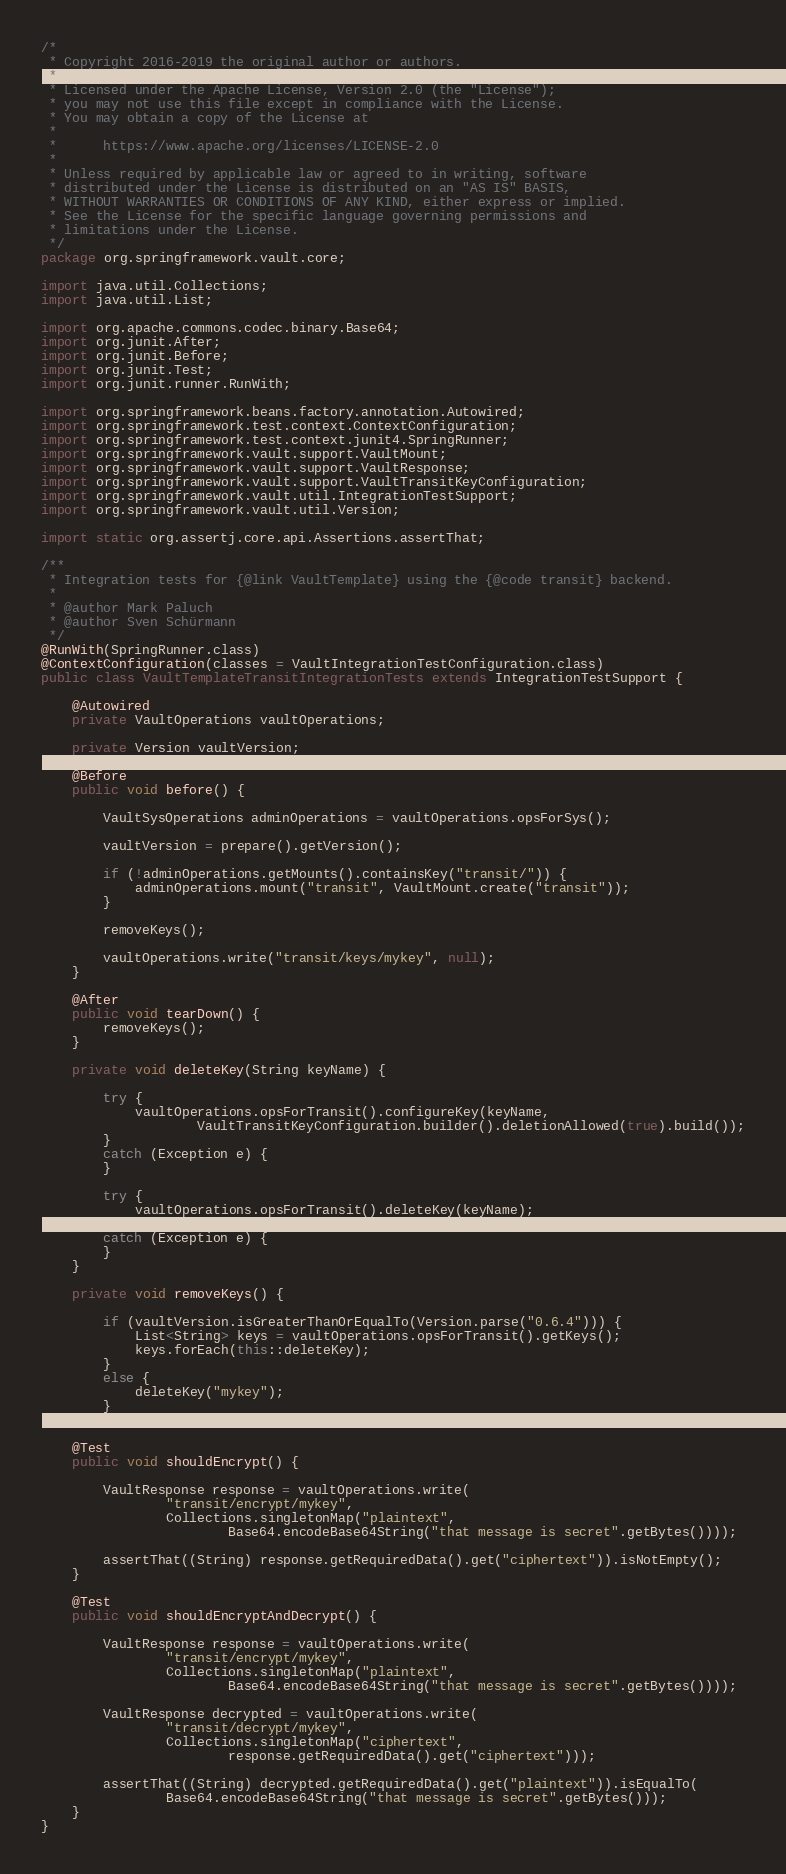Convert code to text. <code><loc_0><loc_0><loc_500><loc_500><_Java_>/*
 * Copyright 2016-2019 the original author or authors.
 *
 * Licensed under the Apache License, Version 2.0 (the "License");
 * you may not use this file except in compliance with the License.
 * You may obtain a copy of the License at
 *
 *      https://www.apache.org/licenses/LICENSE-2.0
 *
 * Unless required by applicable law or agreed to in writing, software
 * distributed under the License is distributed on an "AS IS" BASIS,
 * WITHOUT WARRANTIES OR CONDITIONS OF ANY KIND, either express or implied.
 * See the License for the specific language governing permissions and
 * limitations under the License.
 */
package org.springframework.vault.core;

import java.util.Collections;
import java.util.List;

import org.apache.commons.codec.binary.Base64;
import org.junit.After;
import org.junit.Before;
import org.junit.Test;
import org.junit.runner.RunWith;

import org.springframework.beans.factory.annotation.Autowired;
import org.springframework.test.context.ContextConfiguration;
import org.springframework.test.context.junit4.SpringRunner;
import org.springframework.vault.support.VaultMount;
import org.springframework.vault.support.VaultResponse;
import org.springframework.vault.support.VaultTransitKeyConfiguration;
import org.springframework.vault.util.IntegrationTestSupport;
import org.springframework.vault.util.Version;

import static org.assertj.core.api.Assertions.assertThat;

/**
 * Integration tests for {@link VaultTemplate} using the {@code transit} backend.
 *
 * @author Mark Paluch
 * @author Sven Schürmann
 */
@RunWith(SpringRunner.class)
@ContextConfiguration(classes = VaultIntegrationTestConfiguration.class)
public class VaultTemplateTransitIntegrationTests extends IntegrationTestSupport {

	@Autowired
	private VaultOperations vaultOperations;

	private Version vaultVersion;

	@Before
	public void before() {

		VaultSysOperations adminOperations = vaultOperations.opsForSys();

		vaultVersion = prepare().getVersion();

		if (!adminOperations.getMounts().containsKey("transit/")) {
			adminOperations.mount("transit", VaultMount.create("transit"));
		}

		removeKeys();

		vaultOperations.write("transit/keys/mykey", null);
	}

	@After
	public void tearDown() {
		removeKeys();
	}

	private void deleteKey(String keyName) {

		try {
			vaultOperations.opsForTransit().configureKey(keyName,
					VaultTransitKeyConfiguration.builder().deletionAllowed(true).build());
		}
		catch (Exception e) {
		}

		try {
			vaultOperations.opsForTransit().deleteKey(keyName);
		}
		catch (Exception e) {
		}
	}

	private void removeKeys() {

		if (vaultVersion.isGreaterThanOrEqualTo(Version.parse("0.6.4"))) {
			List<String> keys = vaultOperations.opsForTransit().getKeys();
			keys.forEach(this::deleteKey);
		}
		else {
			deleteKey("mykey");
		}
	}

	@Test
	public void shouldEncrypt() {

		VaultResponse response = vaultOperations.write(
				"transit/encrypt/mykey",
				Collections.singletonMap("plaintext",
						Base64.encodeBase64String("that message is secret".getBytes())));

		assertThat((String) response.getRequiredData().get("ciphertext")).isNotEmpty();
	}

	@Test
	public void shouldEncryptAndDecrypt() {

		VaultResponse response = vaultOperations.write(
				"transit/encrypt/mykey",
				Collections.singletonMap("plaintext",
						Base64.encodeBase64String("that message is secret".getBytes())));

		VaultResponse decrypted = vaultOperations.write(
				"transit/decrypt/mykey",
				Collections.singletonMap("ciphertext",
						response.getRequiredData().get("ciphertext")));

		assertThat((String) decrypted.getRequiredData().get("plaintext")).isEqualTo(
				Base64.encodeBase64String("that message is secret".getBytes()));
	}
}
</code> 